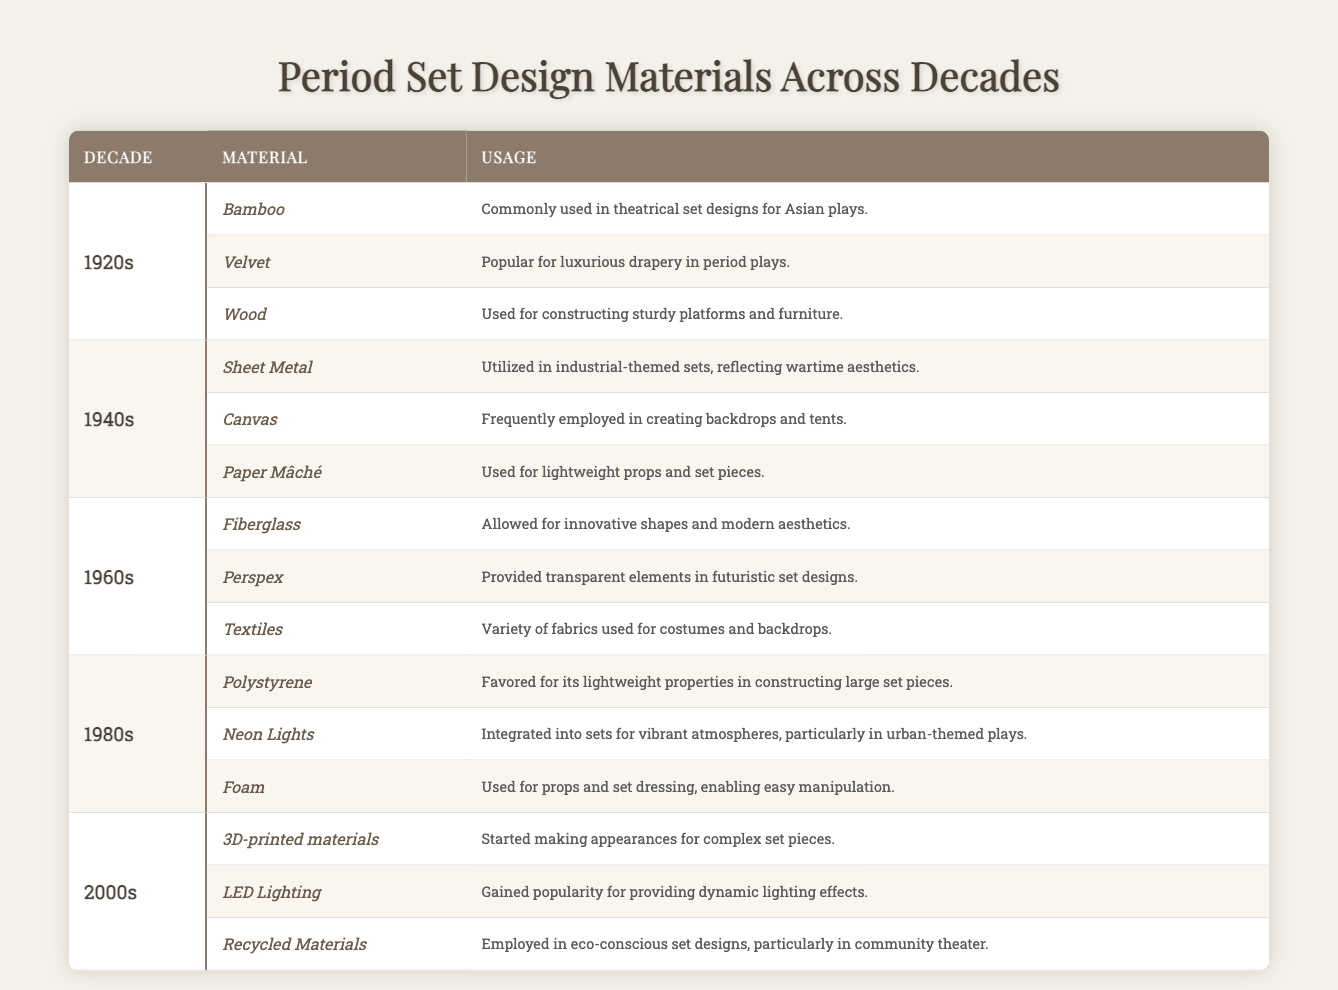What materials were used in the 1920s for period plays? According to the table, the materials used in the 1920s include Bamboo, Velvet, and Wood.
Answer: Bamboo, Velvet, Wood Which decade featured the use of 3D-printed materials? The table indicates that 3D-printed materials started making appearances in the 2000s.
Answer: 2000s In what decade was Paper Mâché commonly used? From the table, it is noted that Paper Mâché was commonly used in the 1940s.
Answer: 1940s What is the primary material listed for the 1980s' urban-themed plays? The table shows that Neon Lights were integrated into sets to create vibrant atmospheres in urban-themed plays during the 1980s.
Answer: Neon Lights How many materials were listed for the 1960s? The 1960s have three materials listed: Fiberglass, Perspex, and Textiles.
Answer: 3 Was Velvet mentioned in the 1940s materials? The table does not include Velvet as a material used in the 1940s; it was instead listed for the 1920s.
Answer: No Which material was favored in the 1980s for its lightweight properties? According to the table, Polystyrene was favored for its lightweight properties in the 1980s.
Answer: Polystyrene What type of materials were preferred for eco-conscious set designs in the 2000s? The table states that Recycled Materials were employed for eco-conscious set designs in the 2000s.
Answer: Recycled Materials Which decade shows a transition from traditional to modern materials in set design? In the table, the transition to modern materials is indicated in the 1960s, with the introduction of Fiberglass and Perspex.
Answer: 1960s Count the total number of unique materials listed in the table across all decades. The materials listed are: Bamboo, Velvet, Wood, Sheet Metal, Canvas, Paper Mâché, Fiberglass, Perspex, Textiles, Polystyrene, Neon Lights, Foam, 3D-printed materials, LED Lighting, and Recycled Materials, totaling 15 unique materials.
Answer: 15 Which decade utilized Canvas for creating backdrops and tents? The table specifies that Canvas was frequently employed in the 1940s for creating backdrops and tents.
Answer: 1940s 